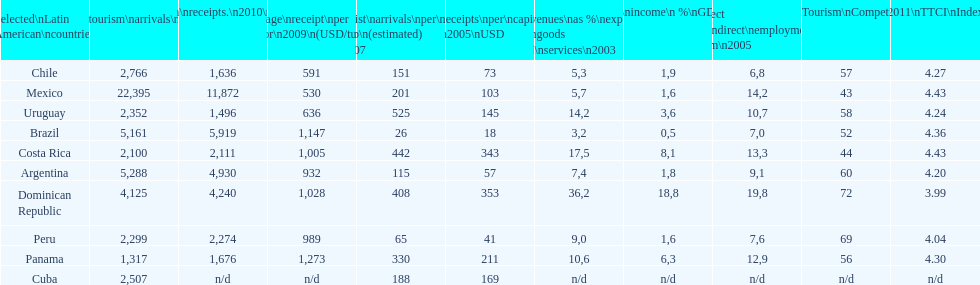What was the average amount of dollars brazil obtained per visitor in 2009? 1,147. 